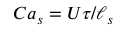<formula> <loc_0><loc_0><loc_500><loc_500>C a _ { s } = U \tau / \ell _ { s }</formula> 